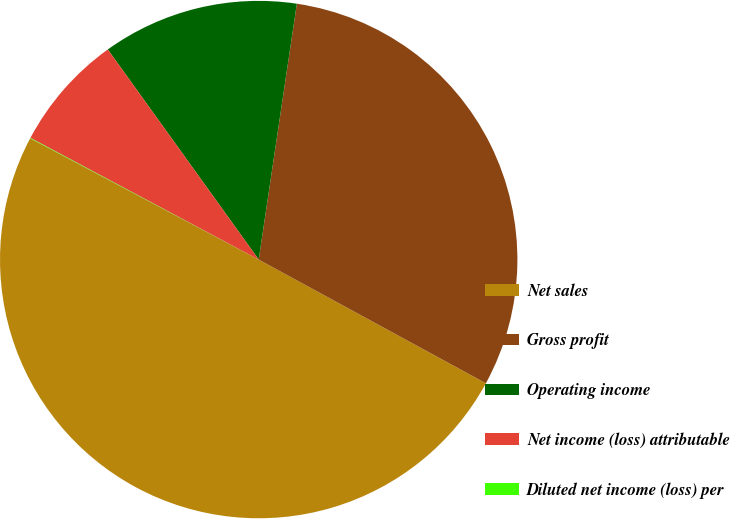Convert chart to OTSL. <chart><loc_0><loc_0><loc_500><loc_500><pie_chart><fcel>Net sales<fcel>Gross profit<fcel>Operating income<fcel>Net income (loss) attributable<fcel>Diluted net income (loss) per<nl><fcel>49.83%<fcel>30.58%<fcel>12.27%<fcel>7.29%<fcel>0.03%<nl></chart> 